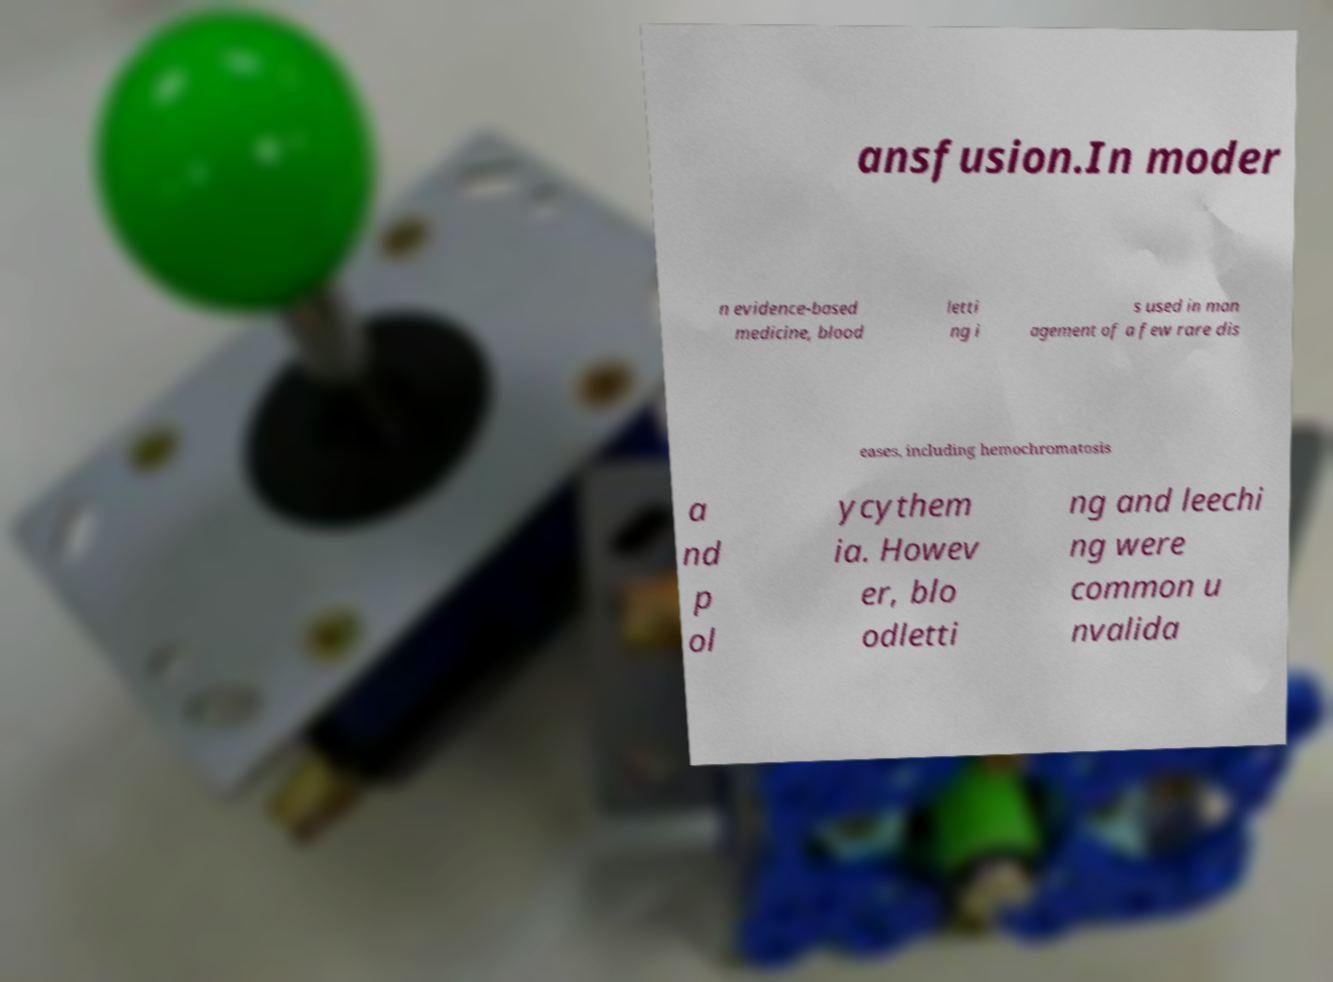What messages or text are displayed in this image? I need them in a readable, typed format. ansfusion.In moder n evidence-based medicine, blood letti ng i s used in man agement of a few rare dis eases, including hemochromatosis a nd p ol ycythem ia. Howev er, blo odletti ng and leechi ng were common u nvalida 